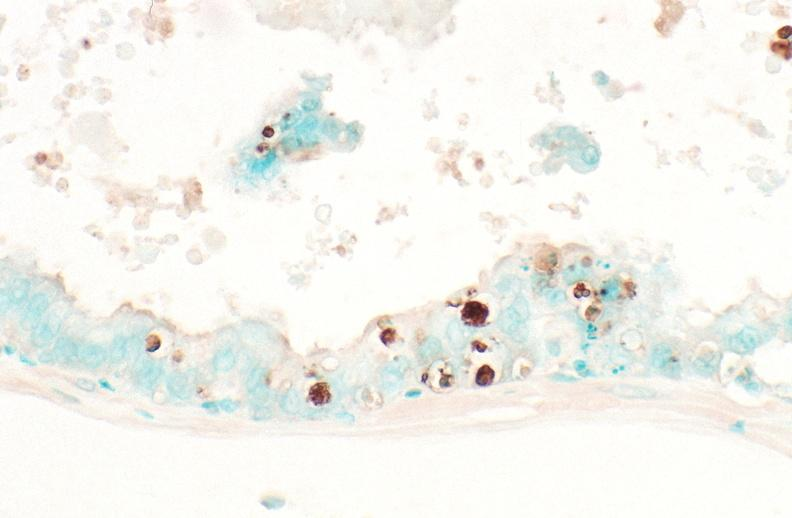what does this image show?
Answer the question using a single word or phrase. Prostate 